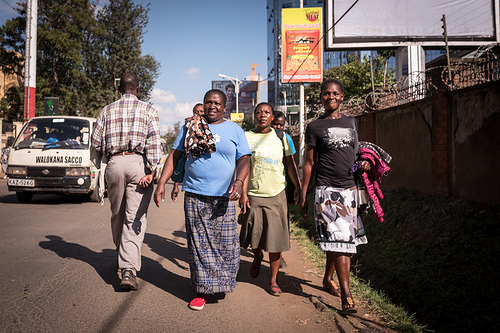<image>
Is the blue lady to the right of the black lady? Yes. From this viewpoint, the blue lady is positioned to the right side relative to the black lady. 